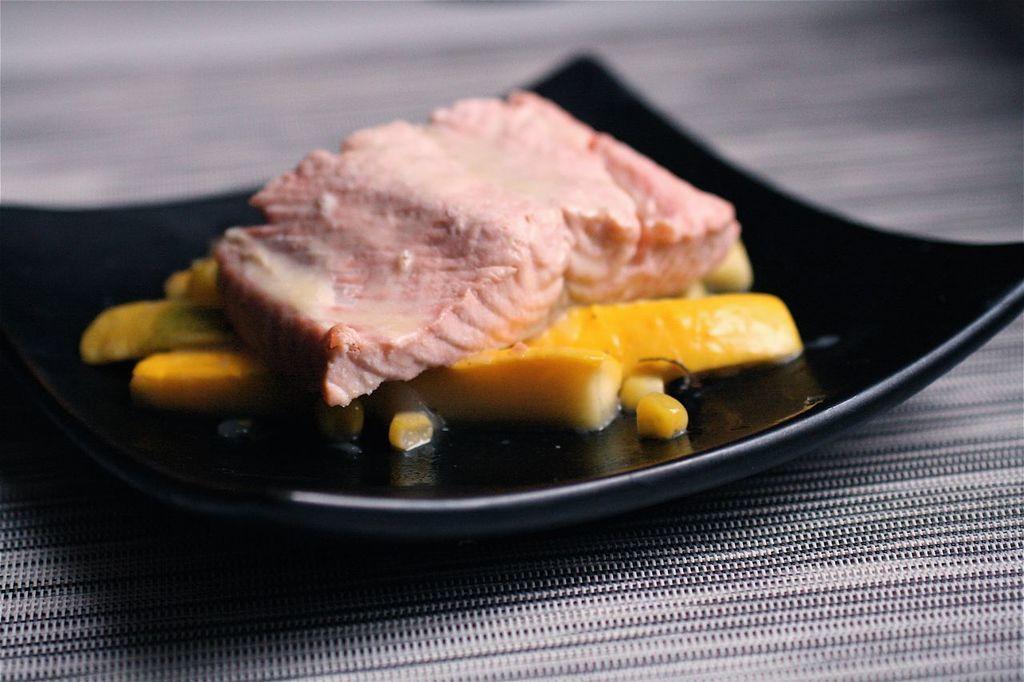Please provide a concise description of this image. In this image there is a table,on the table there is plate in which there is a food item. 